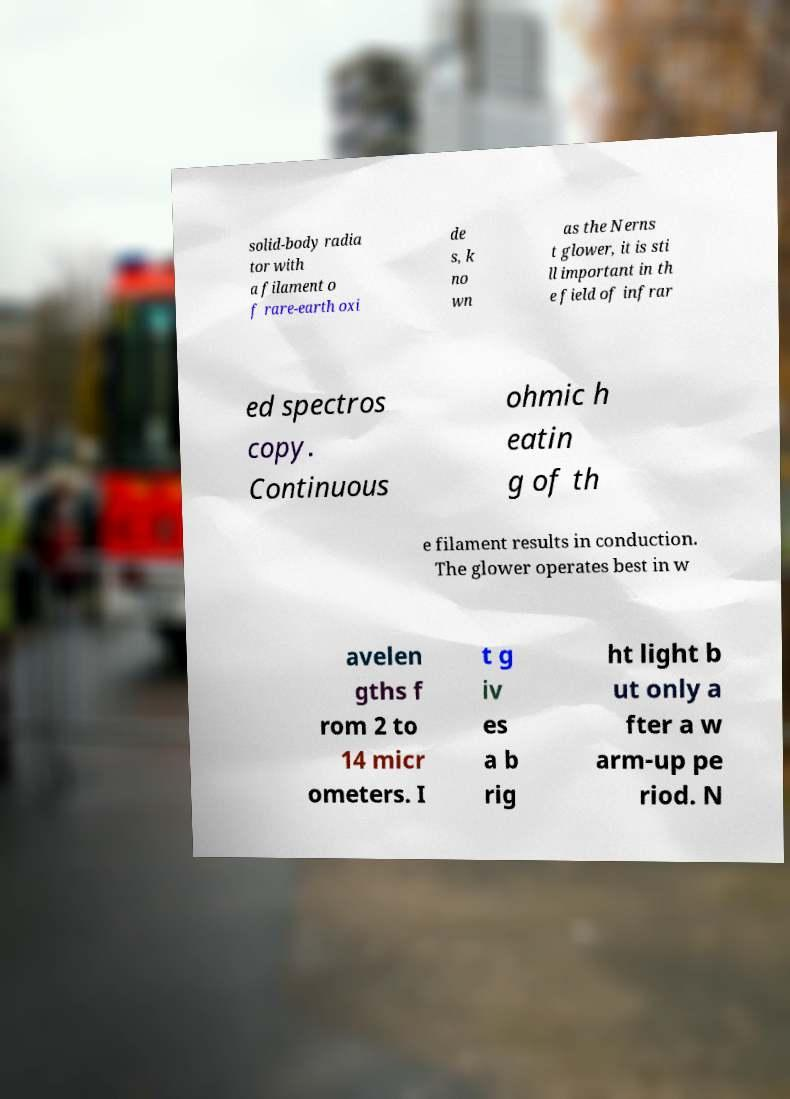I need the written content from this picture converted into text. Can you do that? solid-body radia tor with a filament o f rare-earth oxi de s, k no wn as the Nerns t glower, it is sti ll important in th e field of infrar ed spectros copy. Continuous ohmic h eatin g of th e filament results in conduction. The glower operates best in w avelen gths f rom 2 to 14 micr ometers. I t g iv es a b rig ht light b ut only a fter a w arm-up pe riod. N 